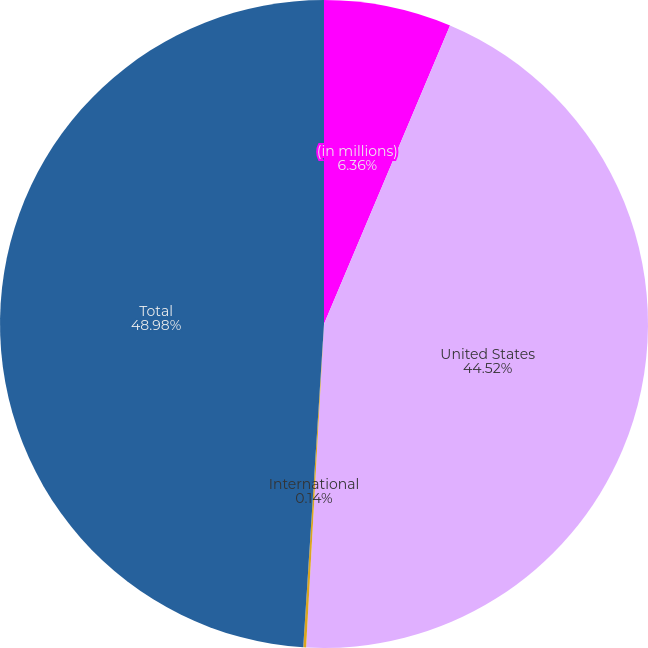Convert chart. <chart><loc_0><loc_0><loc_500><loc_500><pie_chart><fcel>(in millions)<fcel>United States<fcel>International<fcel>Total<nl><fcel>6.36%<fcel>44.52%<fcel>0.14%<fcel>48.98%<nl></chart> 